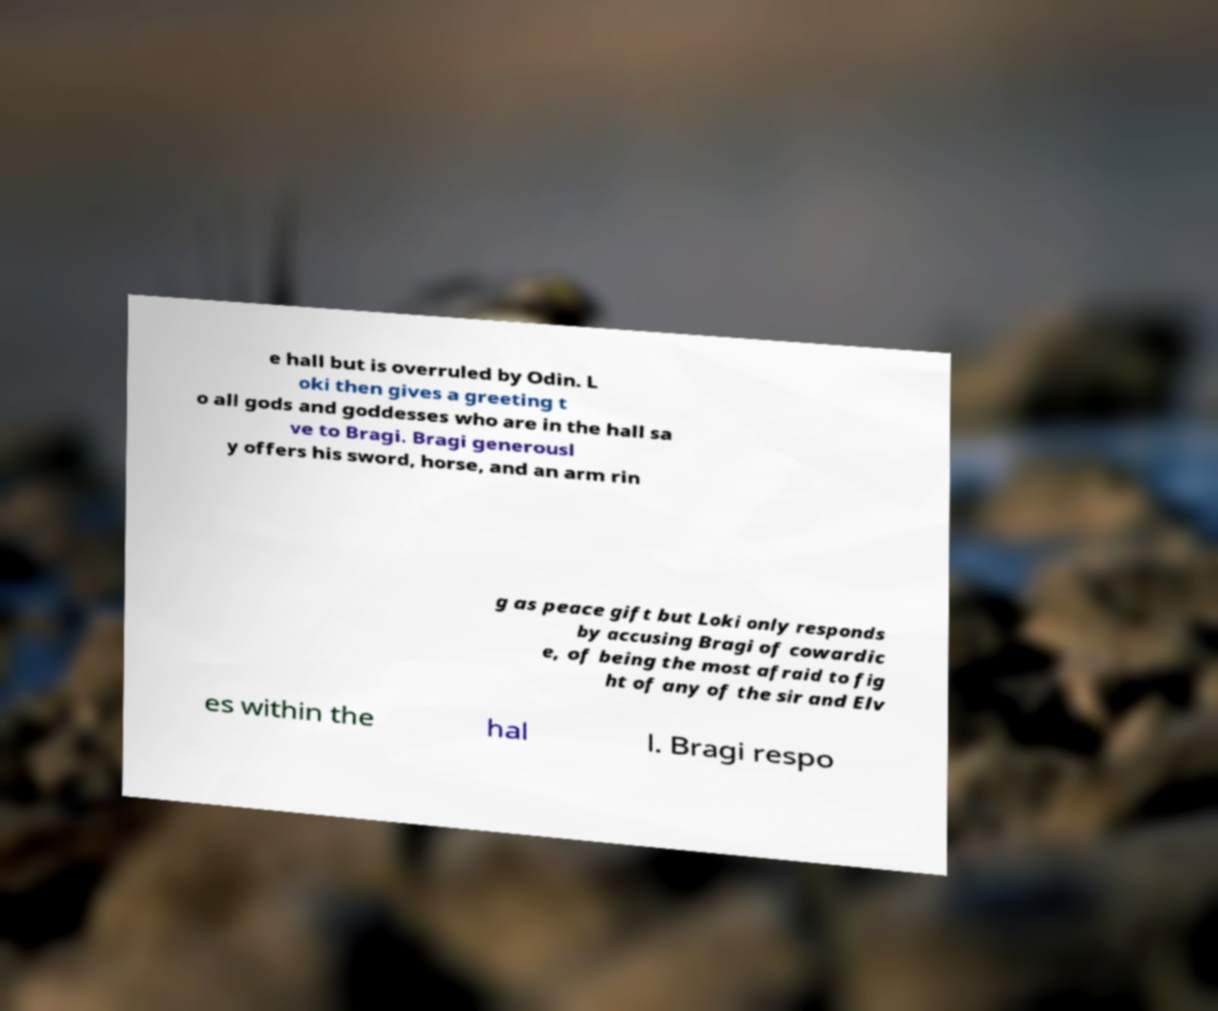Could you assist in decoding the text presented in this image and type it out clearly? e hall but is overruled by Odin. L oki then gives a greeting t o all gods and goddesses who are in the hall sa ve to Bragi. Bragi generousl y offers his sword, horse, and an arm rin g as peace gift but Loki only responds by accusing Bragi of cowardic e, of being the most afraid to fig ht of any of the sir and Elv es within the hal l. Bragi respo 